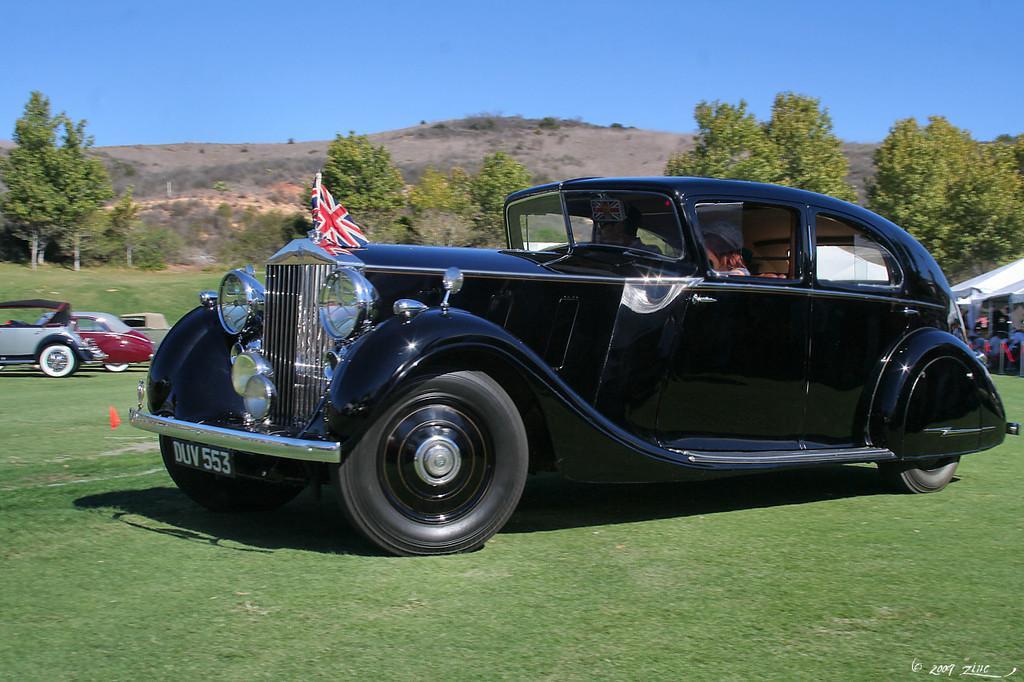Can you describe this image briefly? In the given image i can see a vehicle's,trees,grass,mountains and in the background i can see the sky. 